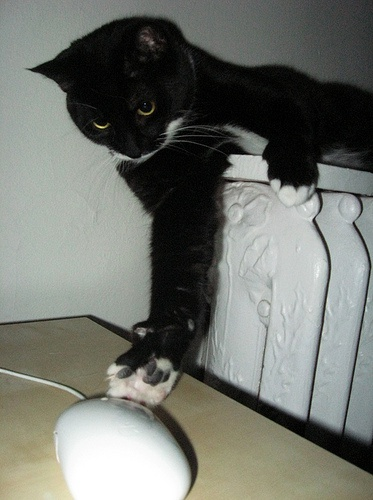Describe the objects in this image and their specific colors. I can see cat in gray, black, darkgray, and lightgray tones, chair in gray, darkgray, lightgray, and black tones, and mouse in gray, white, darkgray, and black tones in this image. 